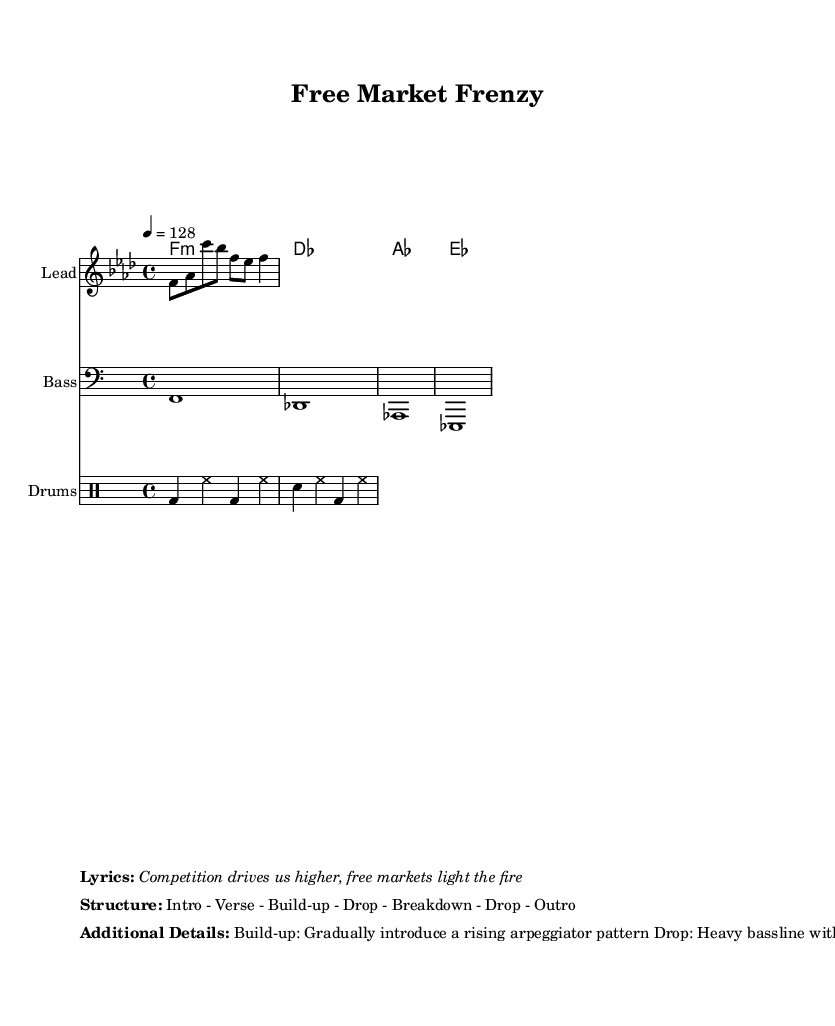What is the key signature of this music? The key signature is indicated by the presence of four flats, which corresponds to F minor. This can be determined by looking at the signature marking at the beginning of the staff.
Answer: F minor What is the time signature of the piece? The time signature is found at the beginning of the score, shown as 4 over 4. This means there are four beats in each measure, and the quarter note gets one beat.
Answer: 4/4 What is the tempo marking of the piece? The tempo is indicated as 4 equals 128, meaning the quarter note should be played at a speed of 128 beats per minute. This is explicitly stated in the tempo marking section of the score.
Answer: 128 How many sections are in the song structure? The structure outlines six sections: Intro, Verse, Build-up, Drop, Breakdown, Drop, and Outro. By counting these sections as listed in the structure markup, we can determine there are seven distinct parts.
Answer: 7 What is the main instrument playing the melody? The melody is played by the staff labeled "Lead." This is indicated by the instrument name inscribed above the corresponding staff that contains the melody notes.
Answer: Lead What is the overall style of the percussion used? The percussion features a basic drum pattern typical for electronic dance music, characterized by kick drum, hi-hats, and snare patterns. This is evident in the notations for the drum staff where specific rhythms are written.
Answer: EDM What does the lyric emphasize about markets? The lyrics emphasize that competition is a driving force and essential for innovation, indicated by the key phrases in the lyrics section of the markup. This is a core theme within the context of free markets.
Answer: Competition 